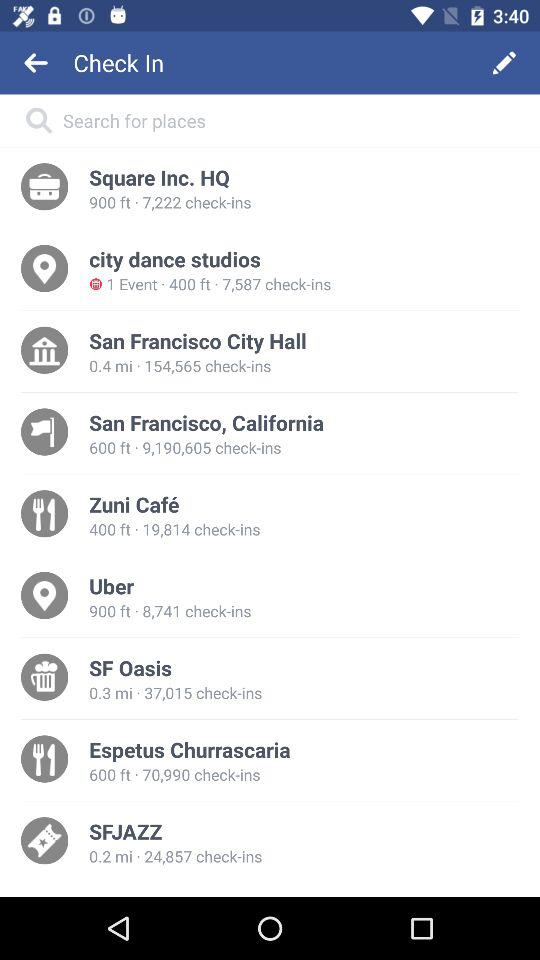What is the distance mentioned for the SFJAZZ? The distance mentioned for the SFJAZZ is 0.2 miles. 